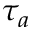Convert formula to latex. <formula><loc_0><loc_0><loc_500><loc_500>\tau _ { a }</formula> 